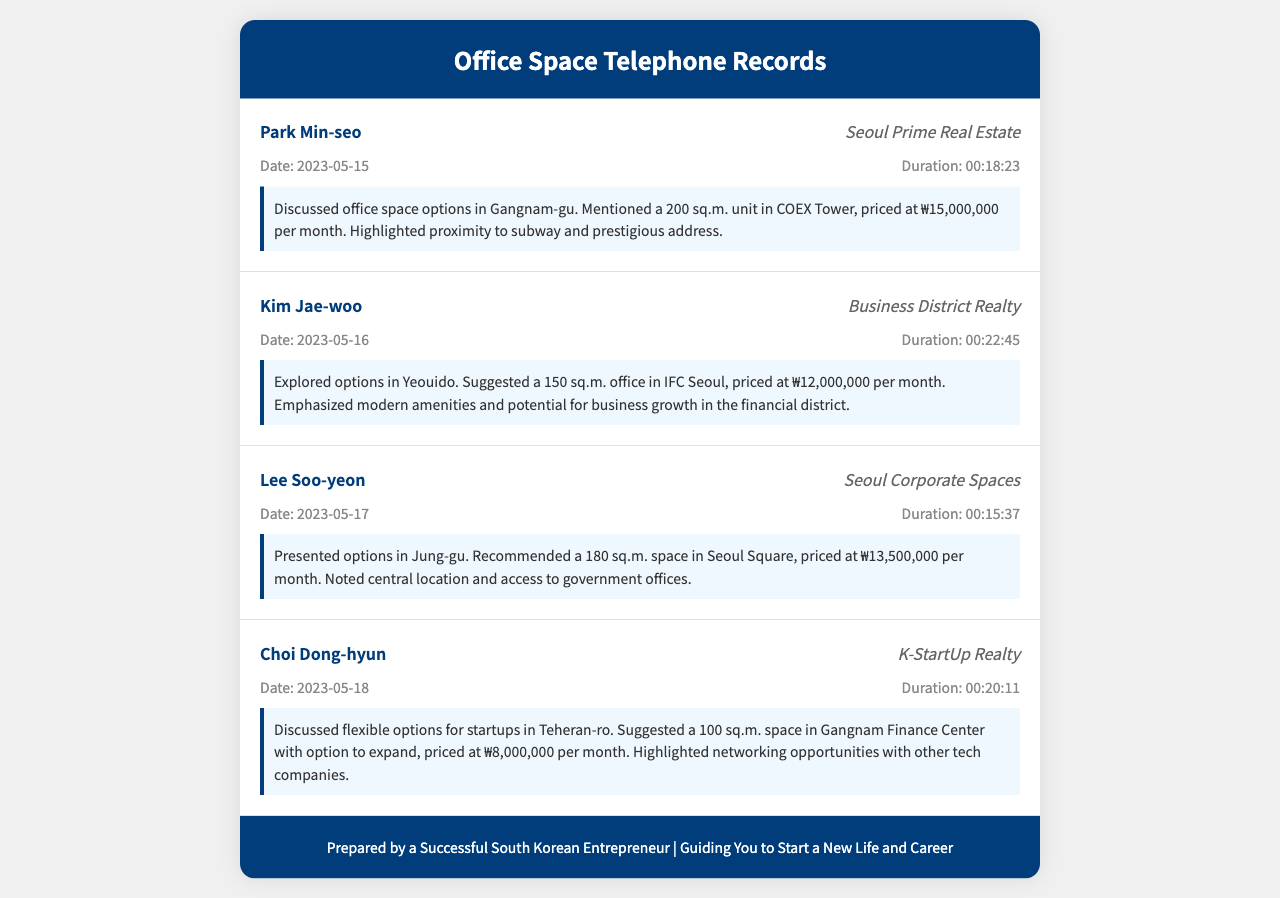What is the name of the first agent? The first agent mentioned in the document is Park Min-seo.
Answer: Park Min-seo What is the price of the office space in COEX Tower? The price for the office space in COEX Tower is ₩15,000,000 per month.
Answer: ₩15,000,000 What location is mentioned for the 150 sq.m. office suggested by Kim Jae-woo? Kim Jae-woo suggested an office located in Yeouido.
Answer: Yeouido What is the size of the office space recommended by Lee Soo-yeon? Lee Soo-yeon recommended a 180 sq.m. office space.
Answer: 180 sq.m Which agency does Choi Dong-hyun represent? Choi Dong-hyun represents K-StartUp Realty.
Answer: K-StartUp Realty What is the duration of the call with Kim Jae-woo? The duration of the call with Kim Jae-woo is 00:22:45.
Answer: 00:22:45 How many sq.m. is the space in Gangnam Finance Center? The space in Gangnam Finance Center is 100 sq.m.
Answer: 100 sq.m What was highlighted about the location suggested by Lee Soo-yeon? Lee Soo-yeon noted access to government offices for the recommended location.
Answer: Access to government offices What can be inferred about the office space in Teheran-ro? The office space in Teheran-ro has options for startups and potential to expand.
Answer: Options for startups and potential to expand What type of properties were discussed in the telephone records? The properties discussed are office spaces in Seoul's business district.
Answer: Office spaces in Seoul's business district 